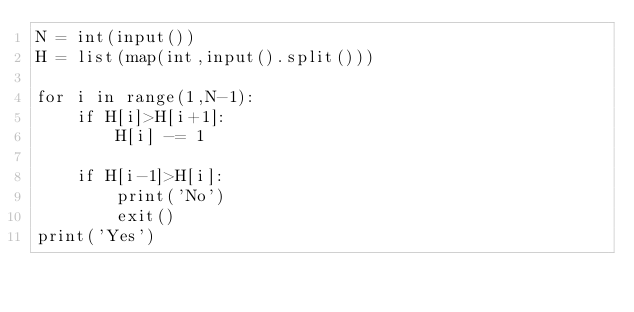Convert code to text. <code><loc_0><loc_0><loc_500><loc_500><_Python_>N = int(input())
H = list(map(int,input().split()))

for i in range(1,N-1):
    if H[i]>H[i+1]:
        H[i] -= 1
        
    if H[i-1]>H[i]:
        print('No')
        exit()
print('Yes')</code> 